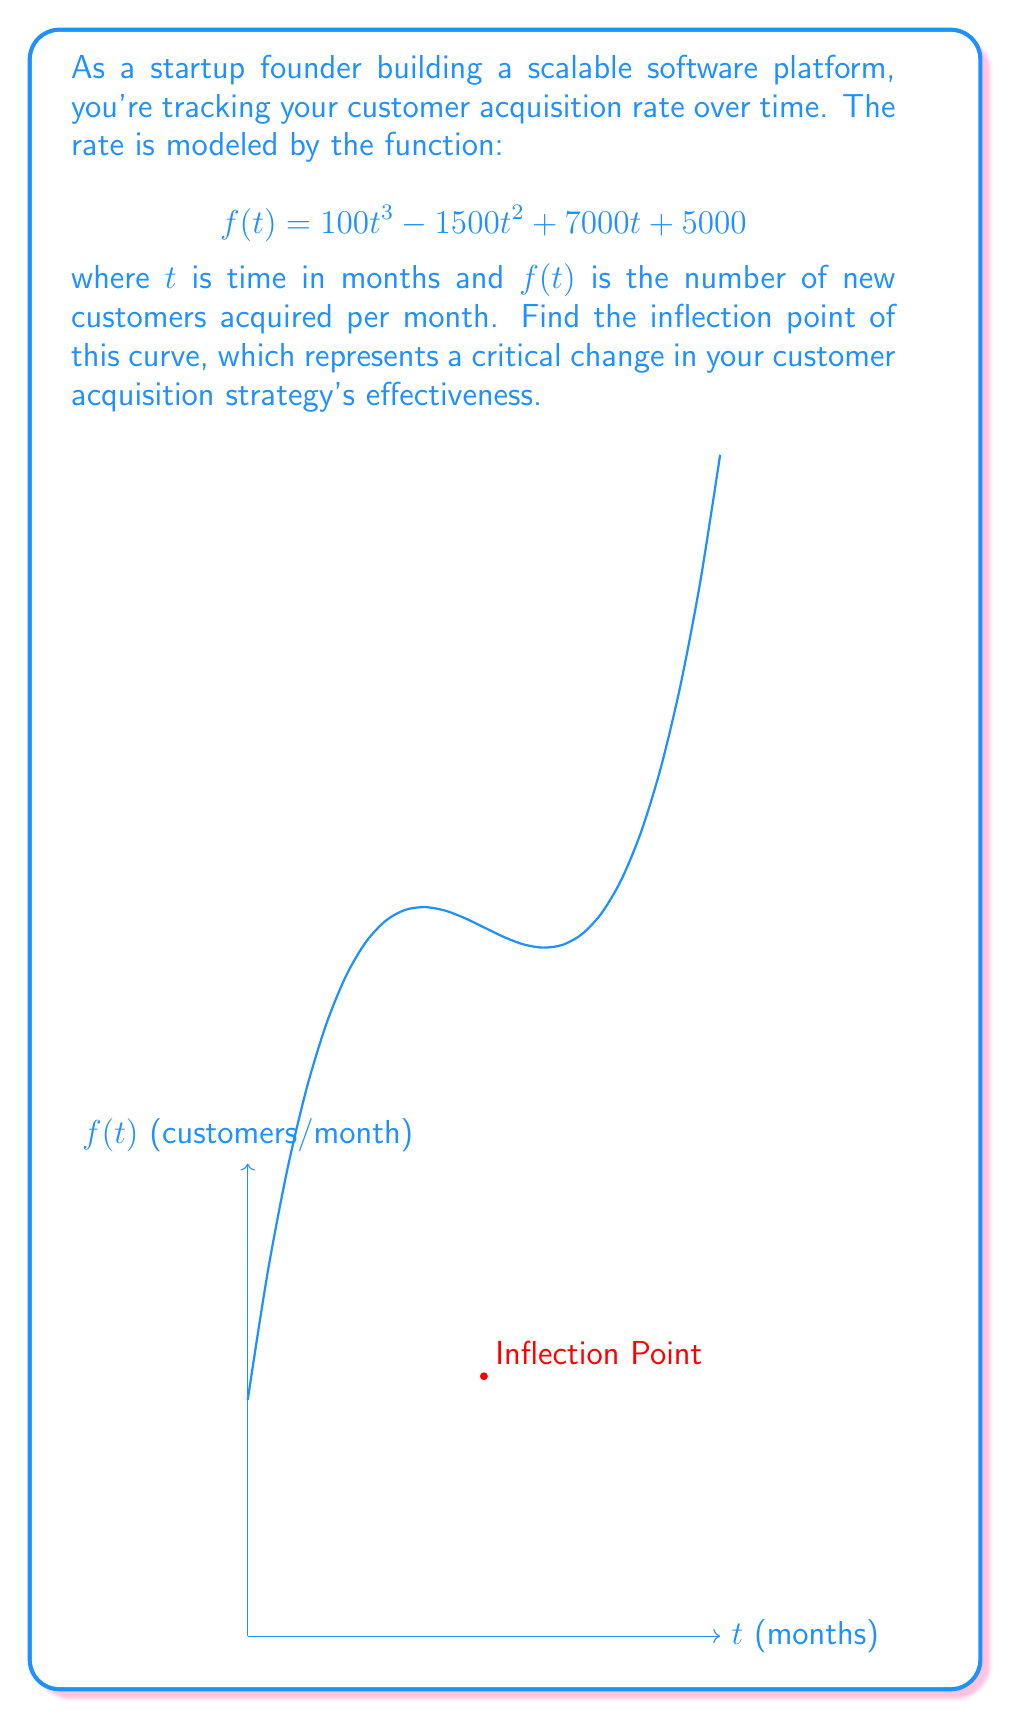Can you answer this question? To find the inflection point, we need to follow these steps:

1) The inflection point occurs where the second derivative of $f(t)$ is zero.

2) First, let's find $f'(t)$:
   $$f'(t) = 300t^2 - 3000t + 7000$$

3) Now, let's find $f''(t)$:
   $$f''(t) = 600t - 3000$$

4) Set $f''(t) = 0$ and solve for $t$:
   $$600t - 3000 = 0$$
   $$600t = 3000$$
   $$t = 5$$

5) To confirm this is an inflection point, we need to verify that $f''(t)$ changes sign at $t=5$:
   For $t < 5$, $f''(t) < 0$
   For $t > 5$, $f''(t) > 0$

6) Now, let's find $f(5)$ to get the y-coordinate of the inflection point:
   $$f(5) = 100(5^3) - 1500(5^2) + 7000(5) + 5000 = 13750$$

Therefore, the inflection point occurs at $(5, 13750)$, meaning after 5 months, your customer acquisition rate is 13,750 new customers per month and the rate of change in acquisition starts to increase.
Answer: $(5, 13750)$ 